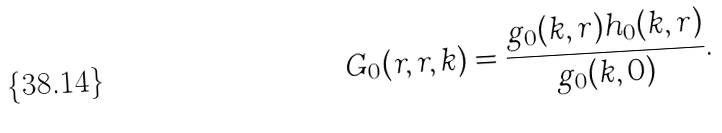<formula> <loc_0><loc_0><loc_500><loc_500>G _ { 0 } ( r , r , k ) = \frac { g _ { 0 } ( k , r ) h _ { 0 } ( k , r ) } { g _ { 0 } ( k , 0 ) } .</formula> 